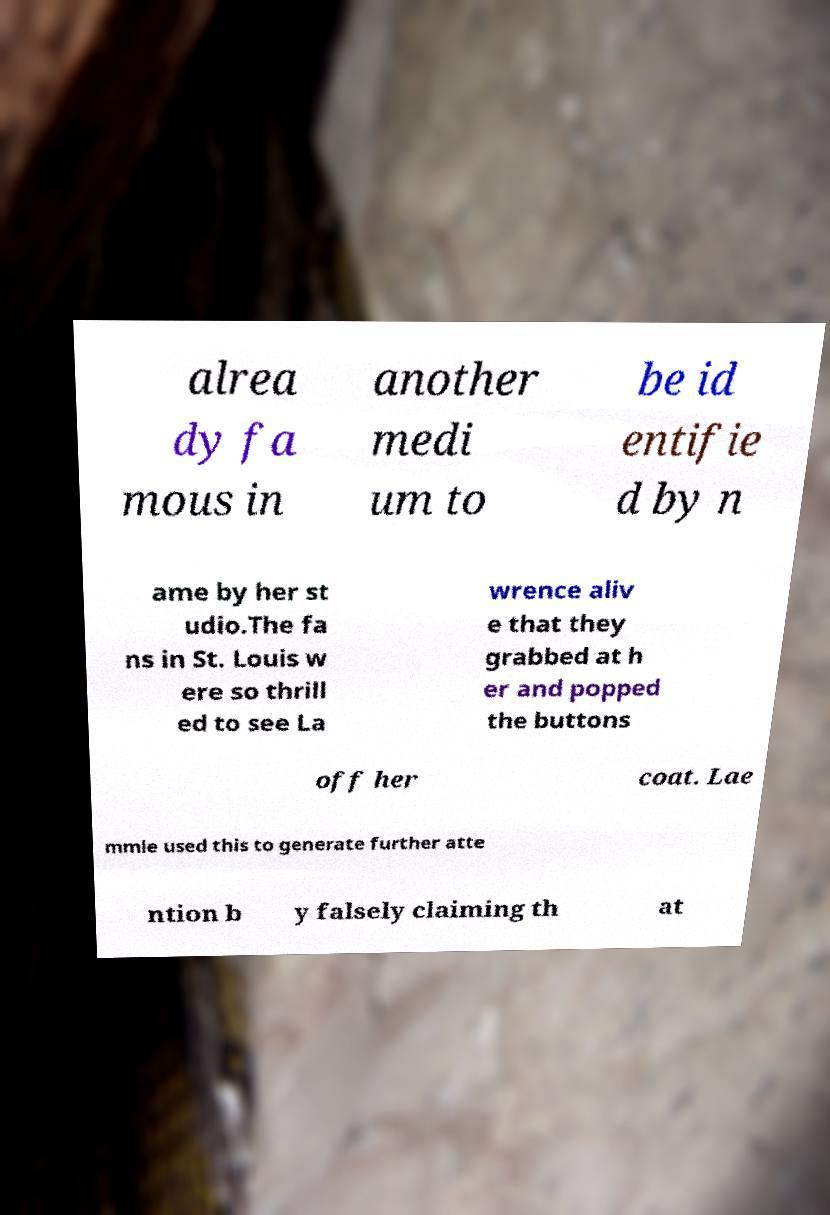Can you accurately transcribe the text from the provided image for me? alrea dy fa mous in another medi um to be id entifie d by n ame by her st udio.The fa ns in St. Louis w ere so thrill ed to see La wrence aliv e that they grabbed at h er and popped the buttons off her coat. Lae mmle used this to generate further atte ntion b y falsely claiming th at 